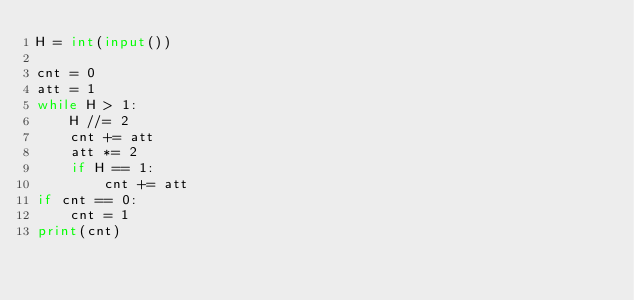Convert code to text. <code><loc_0><loc_0><loc_500><loc_500><_Python_>H = int(input())

cnt = 0
att = 1
while H > 1:
    H //= 2
    cnt += att
    att *= 2
    if H == 1:
        cnt += att
if cnt == 0:
    cnt = 1
print(cnt)
        </code> 